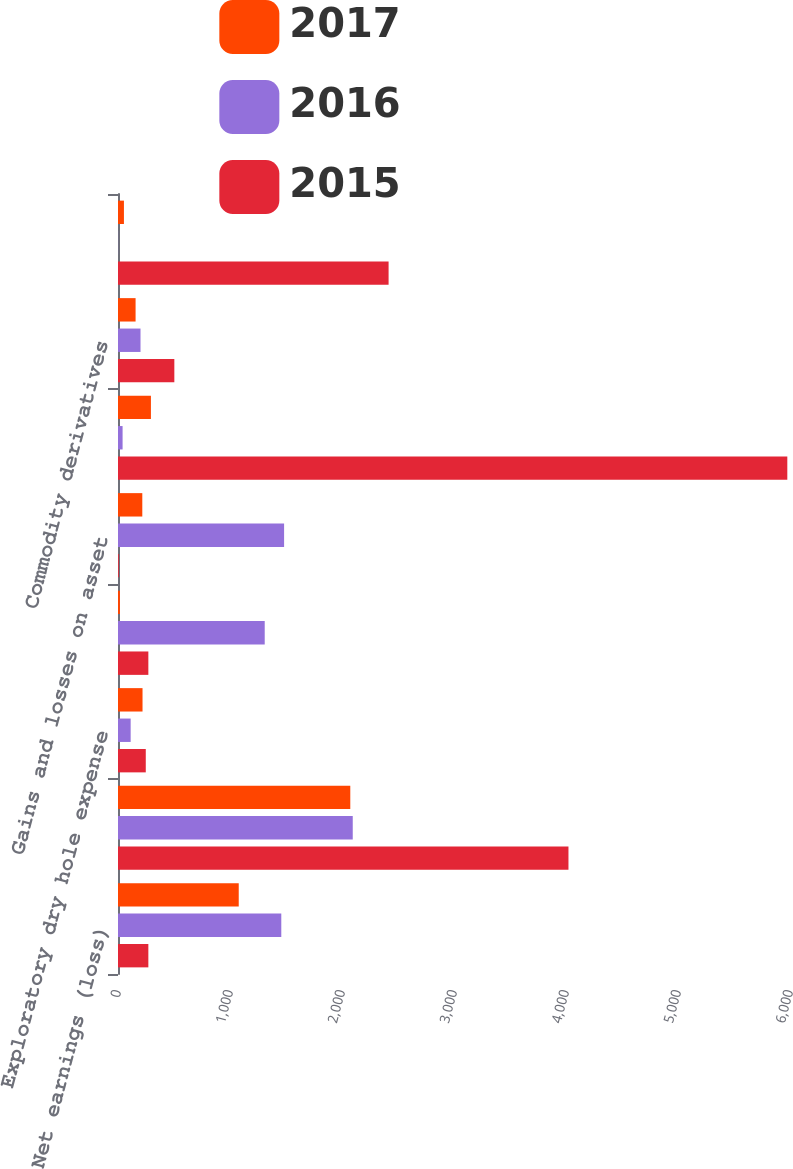Convert chart. <chart><loc_0><loc_0><loc_500><loc_500><stacked_bar_chart><ecel><fcel>Net earnings (loss)<fcel>Depreciation depletion and<fcel>Exploratory dry hole expense<fcel>Asset impairments<fcel>Gains and losses on asset<fcel>Deferred income tax expense<fcel>Commodity derivatives<fcel>Cash settlements on commodity<nl><fcel>2017<fcel>1078<fcel>2074<fcel>219<fcel>17<fcel>217<fcel>294<fcel>157<fcel>53<nl><fcel>2016<fcel>1458<fcel>2096<fcel>113<fcel>1310<fcel>1483<fcel>41<fcel>201<fcel>1<nl><fcel>2015<fcel>271<fcel>4022<fcel>248<fcel>271<fcel>7<fcel>5976<fcel>503<fcel>2416<nl></chart> 